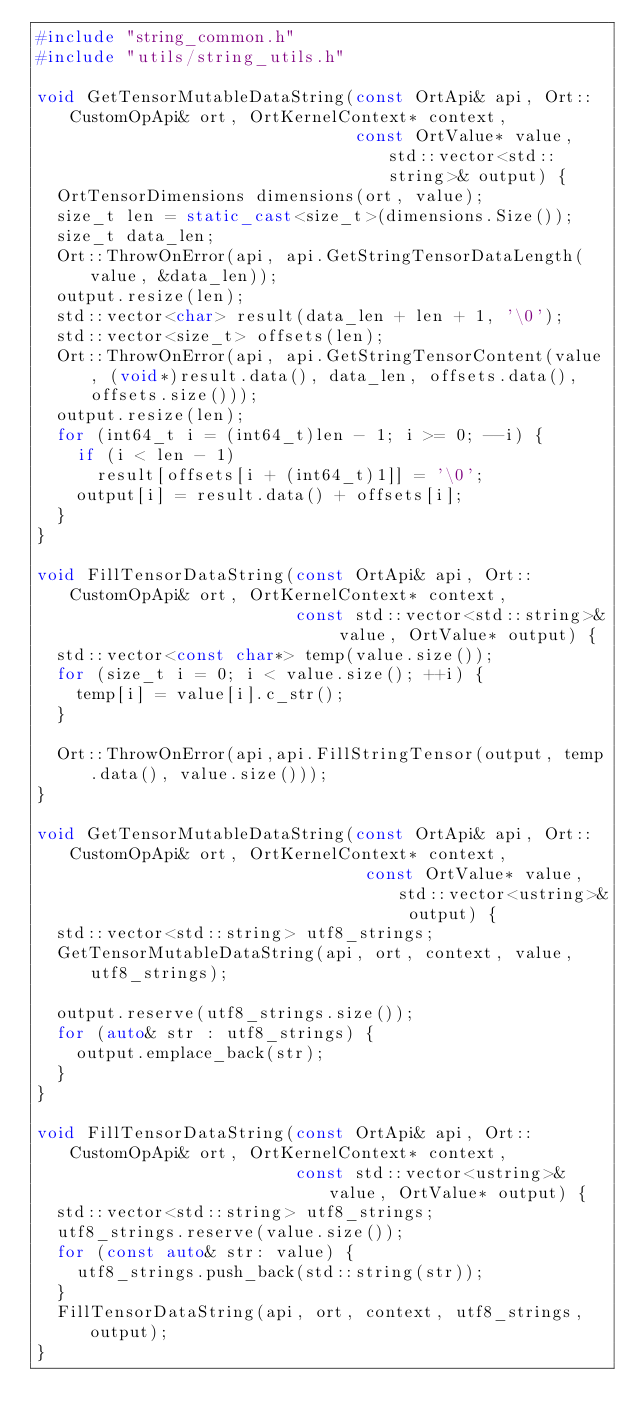<code> <loc_0><loc_0><loc_500><loc_500><_C++_>#include "string_common.h"
#include "utils/string_utils.h"

void GetTensorMutableDataString(const OrtApi& api, Ort::CustomOpApi& ort, OrtKernelContext* context,
                                const OrtValue* value, std::vector<std::string>& output) {
  OrtTensorDimensions dimensions(ort, value);
  size_t len = static_cast<size_t>(dimensions.Size());
  size_t data_len;
  Ort::ThrowOnError(api, api.GetStringTensorDataLength(value, &data_len));
  output.resize(len);
  std::vector<char> result(data_len + len + 1, '\0');
  std::vector<size_t> offsets(len);
  Ort::ThrowOnError(api, api.GetStringTensorContent(value, (void*)result.data(), data_len, offsets.data(), offsets.size()));
  output.resize(len);
  for (int64_t i = (int64_t)len - 1; i >= 0; --i) {
    if (i < len - 1)
      result[offsets[i + (int64_t)1]] = '\0';
    output[i] = result.data() + offsets[i];
  }
}

void FillTensorDataString(const OrtApi& api, Ort::CustomOpApi& ort, OrtKernelContext* context,
                          const std::vector<std::string>& value, OrtValue* output) {
  std::vector<const char*> temp(value.size());
  for (size_t i = 0; i < value.size(); ++i) {
    temp[i] = value[i].c_str();
  }

  Ort::ThrowOnError(api,api.FillStringTensor(output, temp.data(), value.size()));
}

void GetTensorMutableDataString(const OrtApi& api, Ort::CustomOpApi& ort, OrtKernelContext* context,
                                 const OrtValue* value, std::vector<ustring>& output) {
  std::vector<std::string> utf8_strings;
  GetTensorMutableDataString(api, ort, context, value, utf8_strings);

  output.reserve(utf8_strings.size());
  for (auto& str : utf8_strings) {
    output.emplace_back(str);
  }
}

void FillTensorDataString(const OrtApi& api, Ort::CustomOpApi& ort, OrtKernelContext* context,
                          const std::vector<ustring>& value, OrtValue* output) {
  std::vector<std::string> utf8_strings;
  utf8_strings.reserve(value.size());
  for (const auto& str: value) {
    utf8_strings.push_back(std::string(str));
  }
  FillTensorDataString(api, ort, context, utf8_strings, output);
}
</code> 